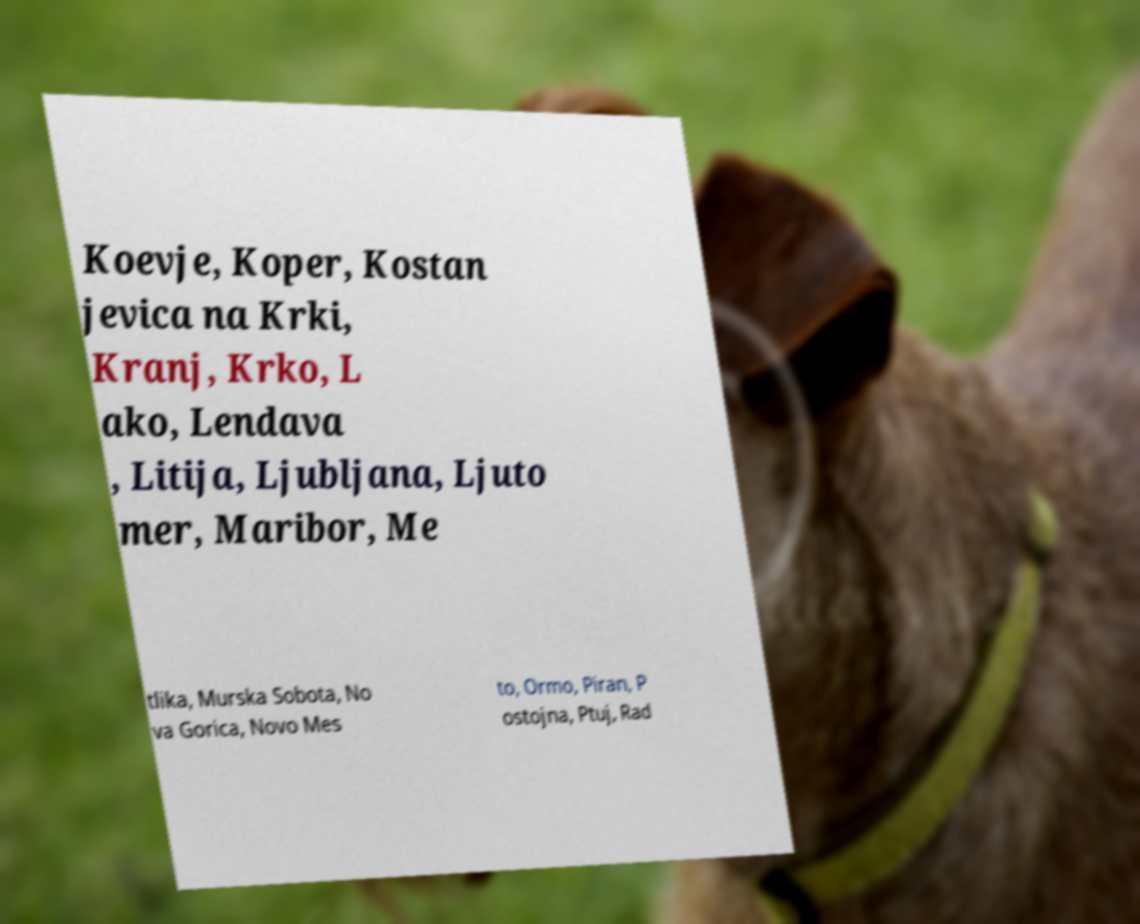Please read and relay the text visible in this image. What does it say? Koevje, Koper, Kostan jevica na Krki, Kranj, Krko, L ako, Lendava , Litija, Ljubljana, Ljuto mer, Maribor, Me tlika, Murska Sobota, No va Gorica, Novo Mes to, Ormo, Piran, P ostojna, Ptuj, Rad 